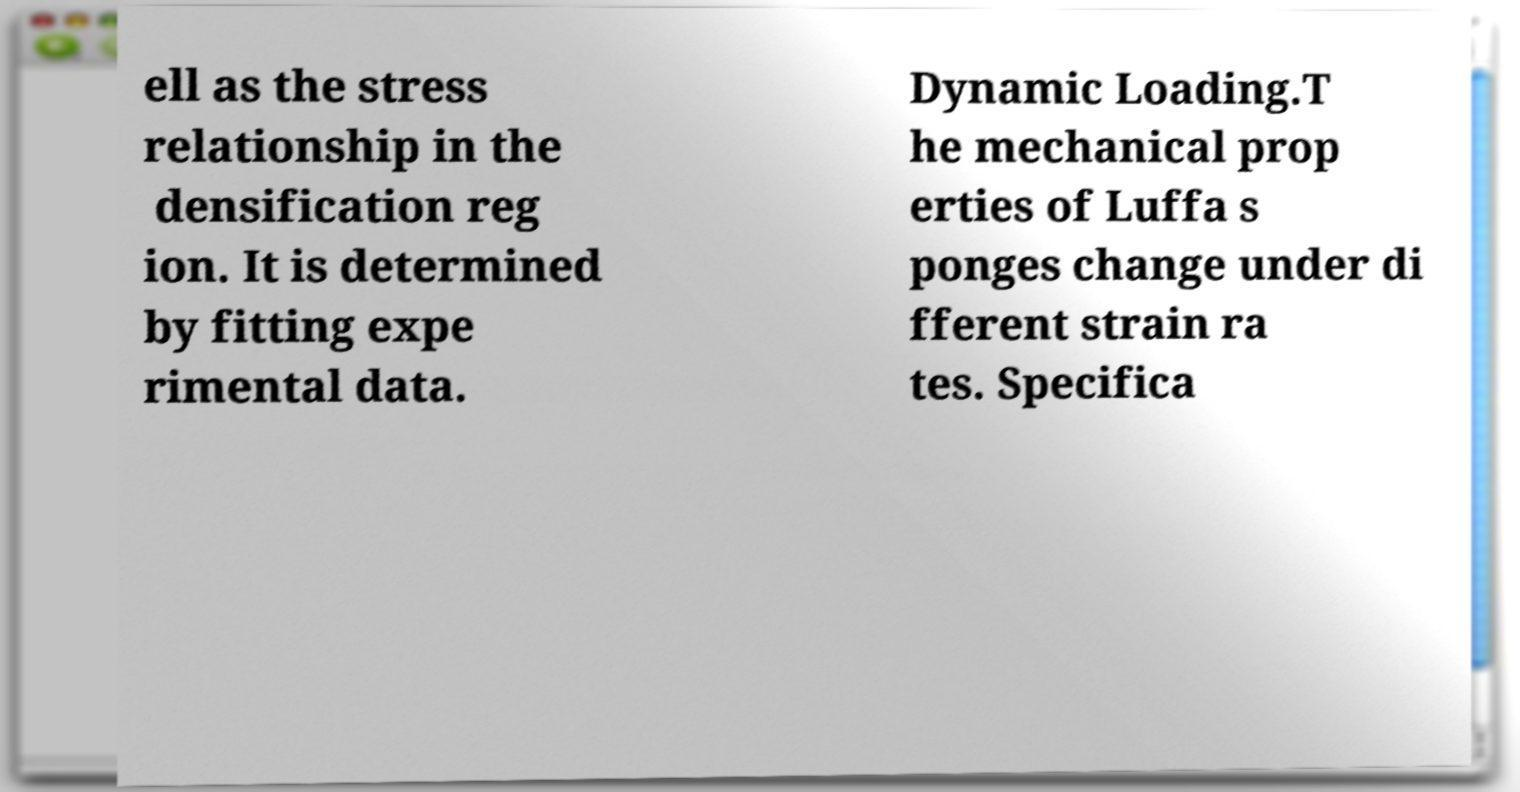For documentation purposes, I need the text within this image transcribed. Could you provide that? ell as the stress relationship in the densification reg ion. It is determined by fitting expe rimental data. Dynamic Loading.T he mechanical prop erties of Luffa s ponges change under di fferent strain ra tes. Specifica 